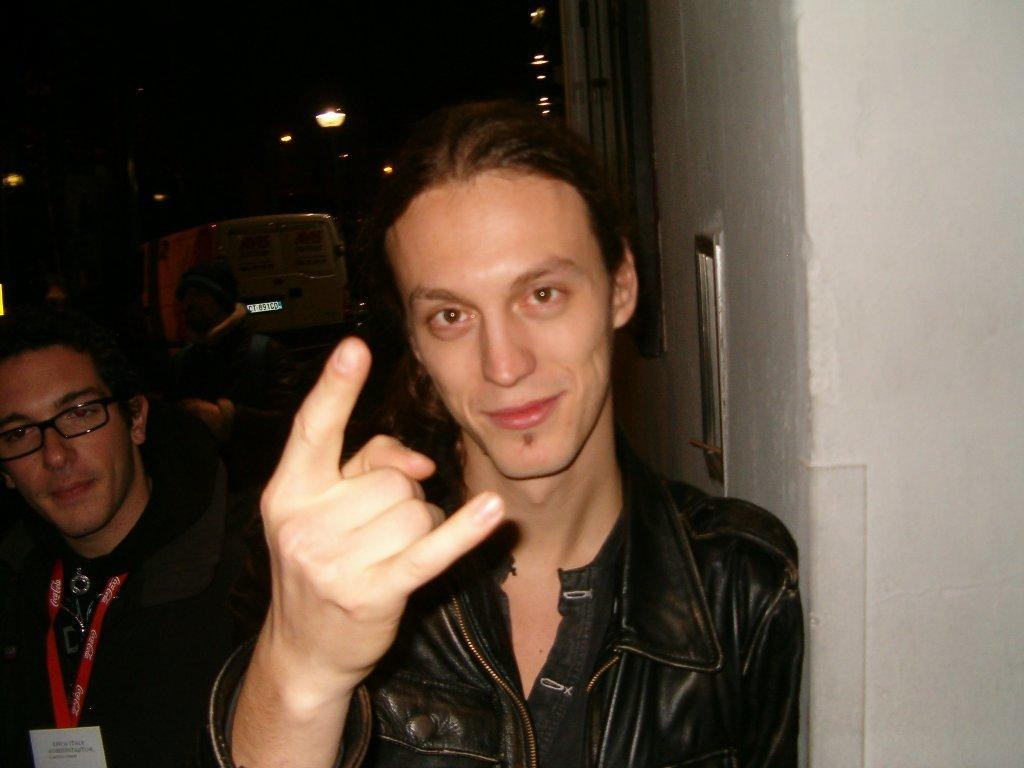What is the main subject of the image? There is a man in the image. What is the man doing with his hands? The man is showing his fingers. What is the man wearing in the image? The man is wearing a black coat. What type of lumber is the man holding in the image? There is no lumber present in the image; the man is showing his fingers. What sign is the man displaying with his fingers in the image? The image does not indicate any specific sign being displayed with the man's fingers. 